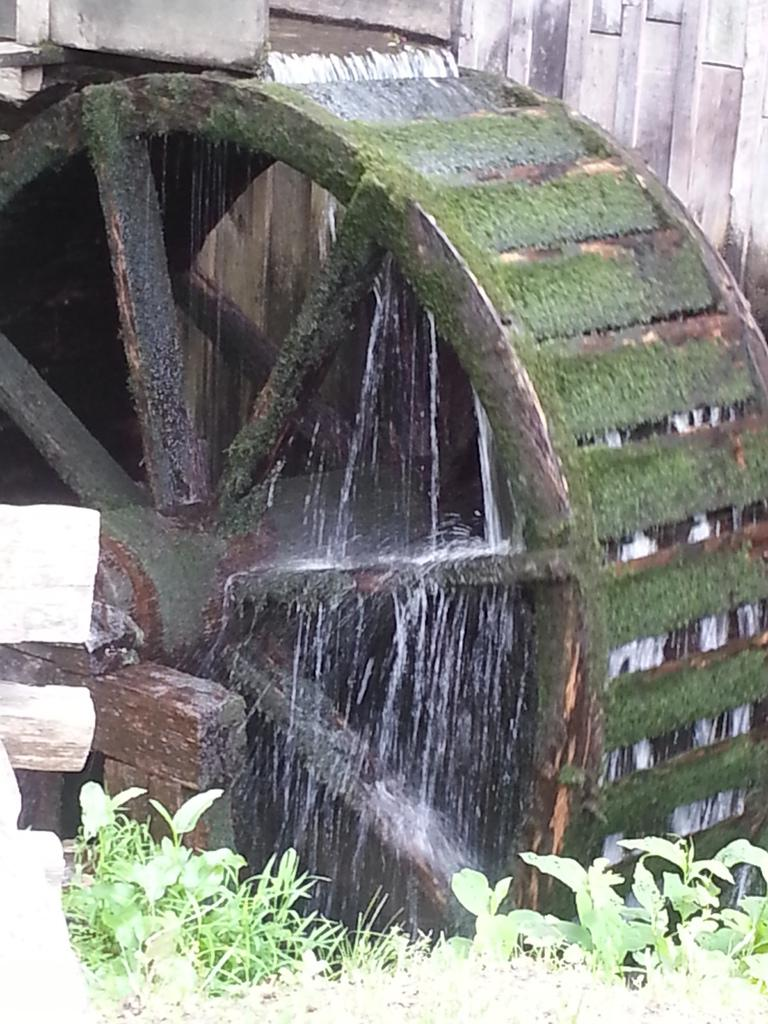What is the main object in the image? There is a wheel-like object in the image. What is happening with the water in the image? Water is flowing in the image. What type of vegetation can be seen in the image? There are green leaves in the image. What type of oven is used for cooking in the image? There is no oven present in the image. How does the digestion process occur in the image? There is no reference to digestion in the image. 